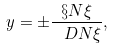<formula> <loc_0><loc_0><loc_500><loc_500>y = \pm \frac { \S N \xi } { \ D N \xi } ,</formula> 